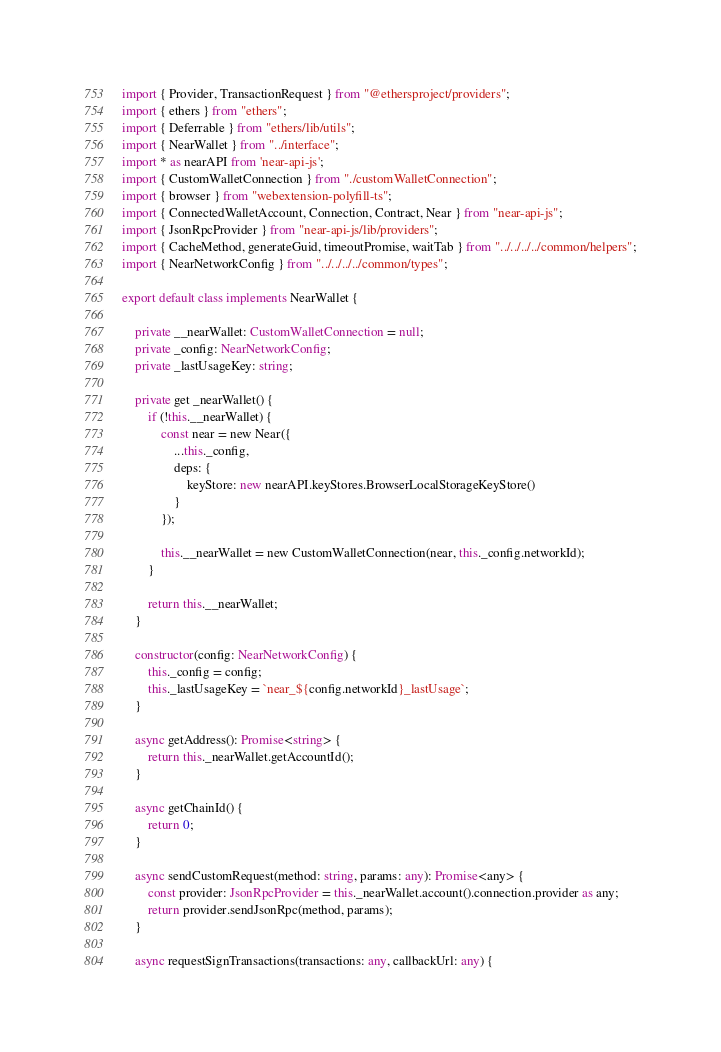<code> <loc_0><loc_0><loc_500><loc_500><_TypeScript_>import { Provider, TransactionRequest } from "@ethersproject/providers";
import { ethers } from "ethers";
import { Deferrable } from "ethers/lib/utils";
import { NearWallet } from "../interface";
import * as nearAPI from 'near-api-js';
import { CustomWalletConnection } from "./customWalletConnection";
import { browser } from "webextension-polyfill-ts";
import { ConnectedWalletAccount, Connection, Contract, Near } from "near-api-js";
import { JsonRpcProvider } from "near-api-js/lib/providers";
import { CacheMethod, generateGuid, timeoutPromise, waitTab } from "../../../../common/helpers";
import { NearNetworkConfig } from "../../../../common/types";

export default class implements NearWallet {

    private __nearWallet: CustomWalletConnection = null;
    private _config: NearNetworkConfig;
    private _lastUsageKey: string;

    private get _nearWallet() {
        if (!this.__nearWallet) {
            const near = new Near({
                ...this._config,
                deps: {
                    keyStore: new nearAPI.keyStores.BrowserLocalStorageKeyStore()
                }
            });

            this.__nearWallet = new CustomWalletConnection(near, this._config.networkId);
        }

        return this.__nearWallet;
    }

    constructor(config: NearNetworkConfig) {
        this._config = config;
        this._lastUsageKey = `near_${config.networkId}_lastUsage`;
    }

    async getAddress(): Promise<string> {
        return this._nearWallet.getAccountId();
    }

    async getChainId() {
        return 0;
    }

    async sendCustomRequest(method: string, params: any): Promise<any> {
        const provider: JsonRpcProvider = this._nearWallet.account().connection.provider as any;
        return provider.sendJsonRpc(method, params);
    }

    async requestSignTransactions(transactions: any, callbackUrl: any) {</code> 